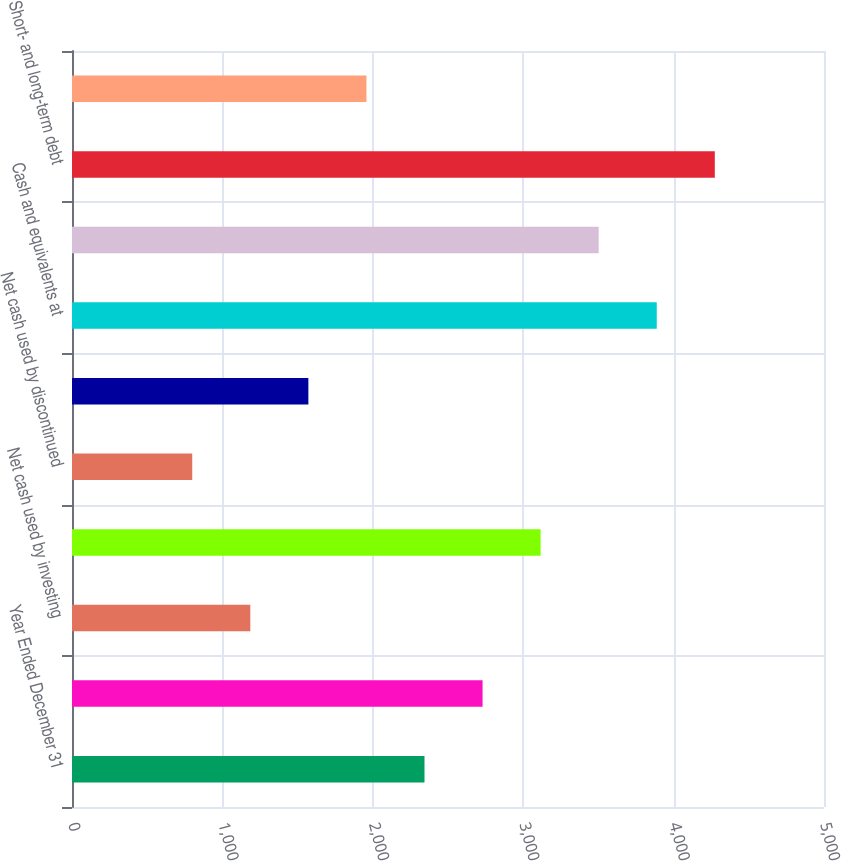Convert chart to OTSL. <chart><loc_0><loc_0><loc_500><loc_500><bar_chart><fcel>Year Ended December 31<fcel>Net cash provided by operating<fcel>Net cash used by investing<fcel>Net cash provided (used) by<fcel>Net cash used by discontinued<fcel>Net (decrease) increase in<fcel>Cash and equivalents at<fcel>Cash and equivalents at end of<fcel>Short- and long-term debt<fcel>Net debt<nl><fcel>2343.76<fcel>2729.82<fcel>1185.58<fcel>3115.88<fcel>799.52<fcel>1571.64<fcel>3888<fcel>3501.94<fcel>4274.06<fcel>1957.7<nl></chart> 